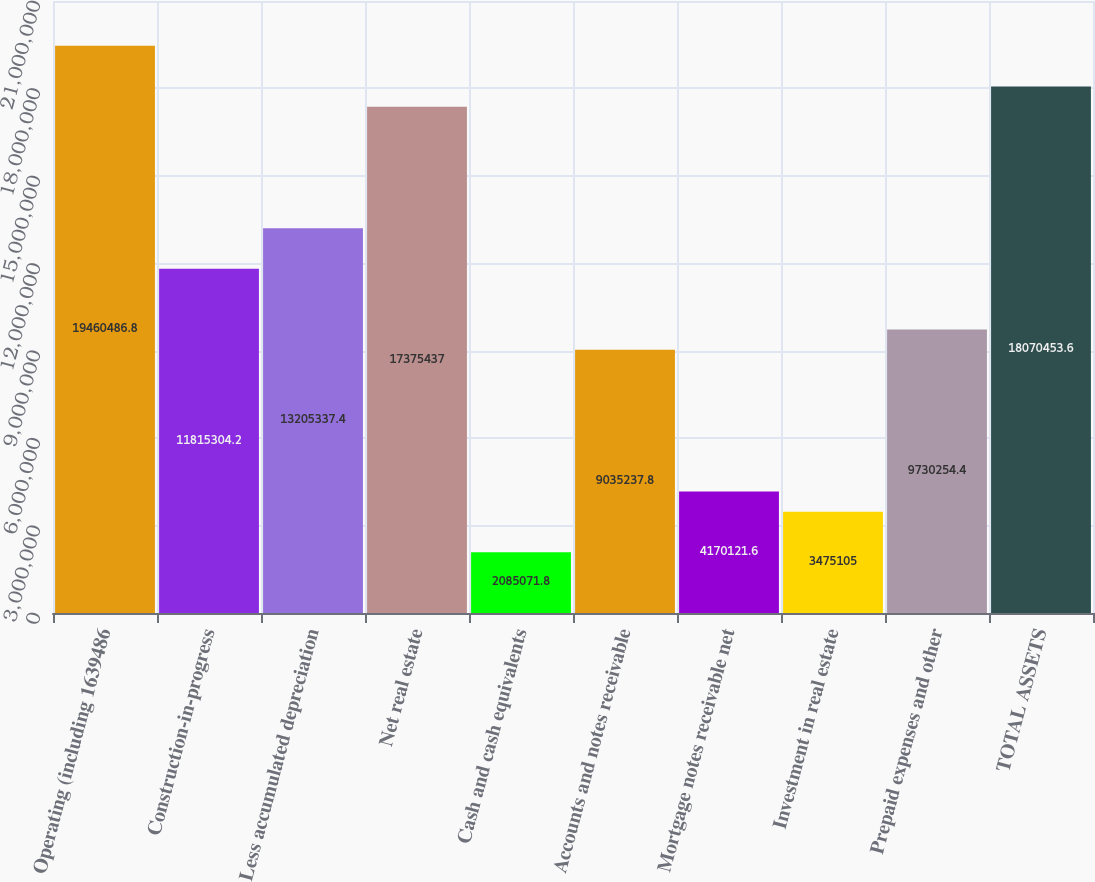Convert chart to OTSL. <chart><loc_0><loc_0><loc_500><loc_500><bar_chart><fcel>Operating (including 1639486<fcel>Construction-in-progress<fcel>Less accumulated depreciation<fcel>Net real estate<fcel>Cash and cash equivalents<fcel>Accounts and notes receivable<fcel>Mortgage notes receivable net<fcel>Investment in real estate<fcel>Prepaid expenses and other<fcel>TOTAL ASSETS<nl><fcel>1.94605e+07<fcel>1.18153e+07<fcel>1.32053e+07<fcel>1.73754e+07<fcel>2.08507e+06<fcel>9.03524e+06<fcel>4.17012e+06<fcel>3.4751e+06<fcel>9.73025e+06<fcel>1.80705e+07<nl></chart> 